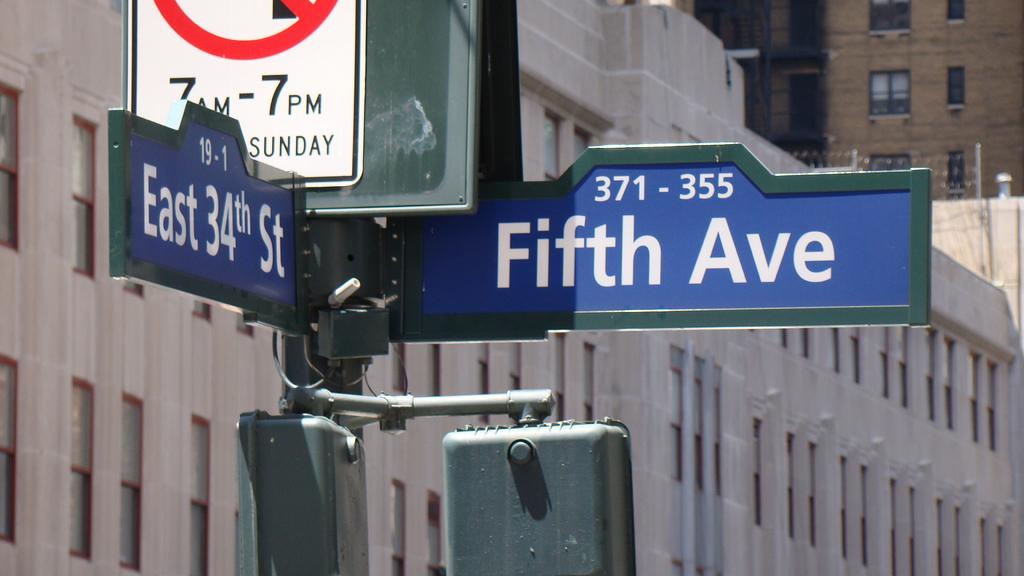What streets are intersecting?
Keep it short and to the point. East 34th and fifth ave. What is the right street?
Your response must be concise. Fifth ave. 